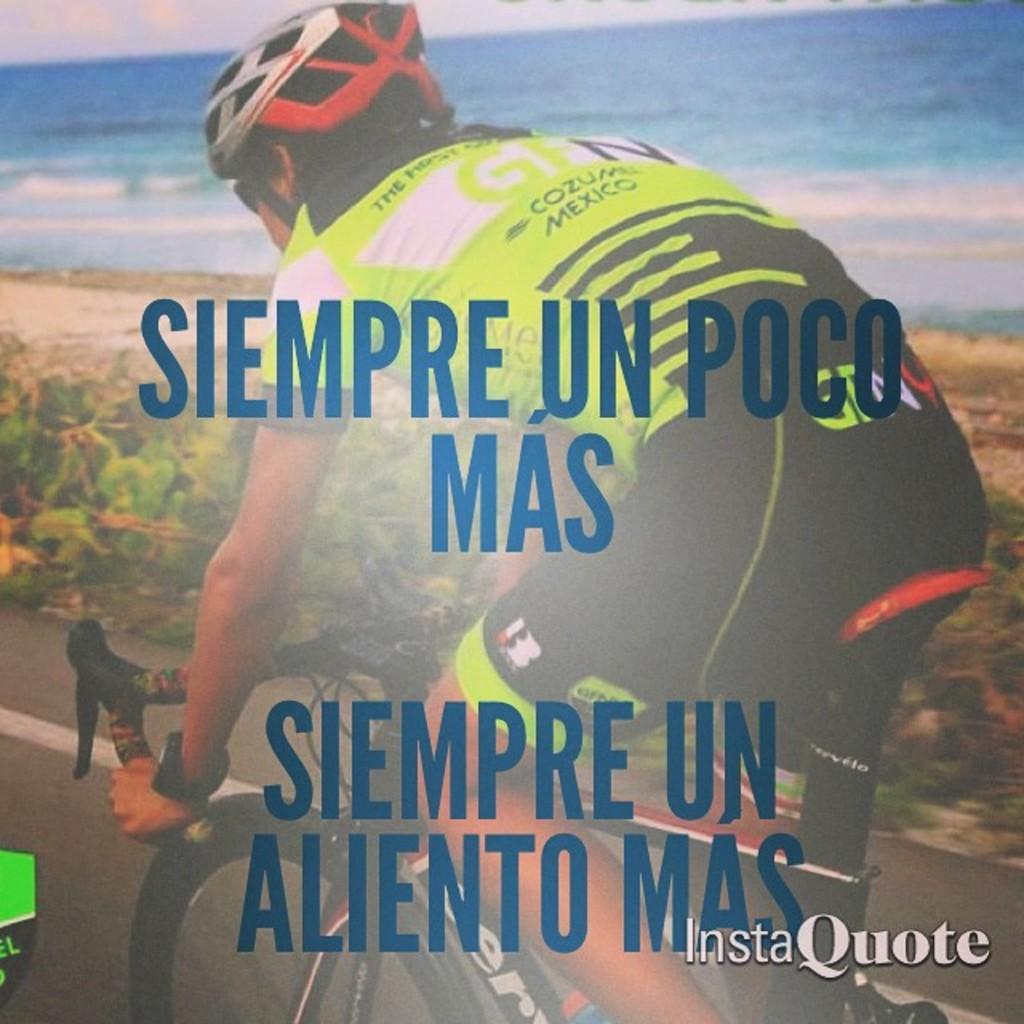Describe this image in one or two sentences. This is an edited picture. In this image there is a person riding bicycle on the road. At the back there are plants and there is water. At the top there is sky and there are clouds. At the bottom there is a road and there is ground. At the bottom right there is text. In the middle of the image there is text. 